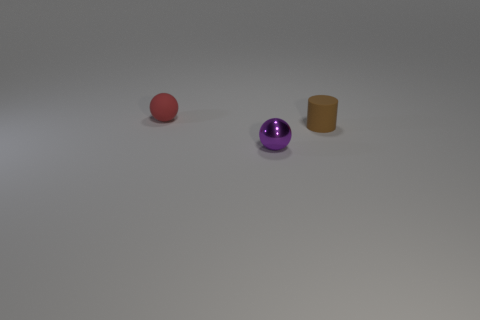Add 2 purple metal spheres. How many objects exist? 5 Subtract all balls. How many objects are left? 1 Add 1 brown things. How many brown things exist? 2 Subtract 0 gray cylinders. How many objects are left? 3 Subtract all small red spheres. Subtract all small blue matte cubes. How many objects are left? 2 Add 1 purple things. How many purple things are left? 2 